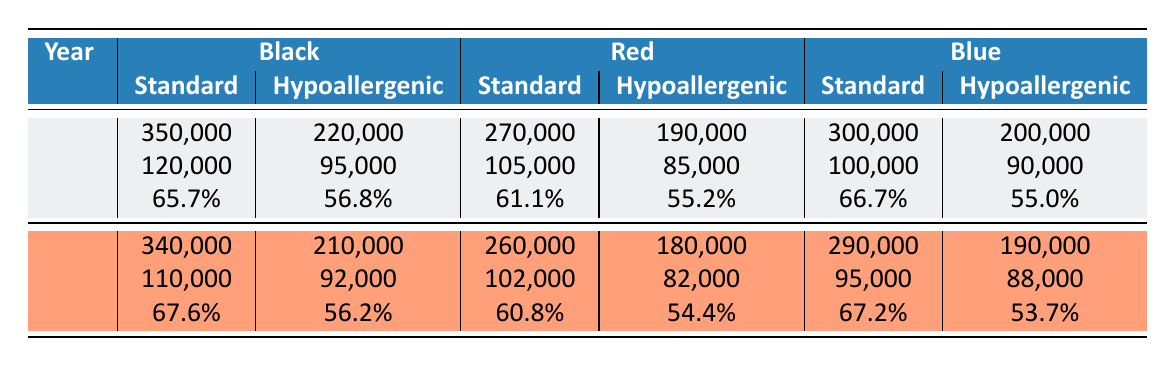What is the gross profit margin for Black Standard ink in 2022? According to the table, the gross profit margin for Black Standard ink in 2022 is specifically noted in the row associated with that category. It states 65.7%.
Answer: 65.7% Which ink color had the highest gross profit margin in 2021? Looking through the gross profit margins for each color in 2021, we see Black Standard at 67.6%, Blue Standard at 67.2%, and the others are lower. Therefore, Black Standard had the highest margin at 67.6%.
Answer: Black Standard What were the total sales for Red Hypoallergenic ink in 2022? The table indicates that the total sales for Red Hypoallergenic ink in 2022 is listed as 190,000.
Answer: 190,000 How much did the costs of goods sold for Blue Standard ink change from 2021 to 2022? The costs of goods sold for Blue Standard ink were 95,000 in 2021 and 100,000 in 2022. The difference is 100,000 - 95,000 = 5,000, indicating an increase.
Answer: 5,000 Is the gross profit margin for Black Hypoallergenic ink in 2022 higher than its value in 2021? The gross profit margin for Black Hypoallergenic ink is 56.8% in 2022 and 56.2% in 2021. Since 56.8% is greater than 56.2%, it is higher.
Answer: Yes What is the average gross profit margin for all hypoallergenic inks across the years? The gross profit margins for hypoallergenic inks are 56.8% (2022), 56.2% (2021), 55.2% (2022), 54.4% (2021), 55.0% (2022), and 53.7% (2021). Summing these gives 56.8 + 56.2 + 55.2 + 54.4 + 55.0 + 53.7 = 331.5. There are 6 data points, so the average is 331.5 / 6 = 55.25.
Answer: 55.25 Which color type had the lowest total sales in 2021? Checking the total sales for each ink color type for 2021, we see Red Hypoallergenic at 180,000 as the lowest when compared to others: Black at 340,000, Red at 260,000, and Blue at 290,000.
Answer: Red Hypoallergenic By how much did total sales for Standard Black ink increase from 2021 to 2022? The total sales for Standard Black ink in 2021 was 340,000 and in 2022 it was 350,000. The increase is 350,000 - 340,000 = 10,000.
Answer: 10,000 